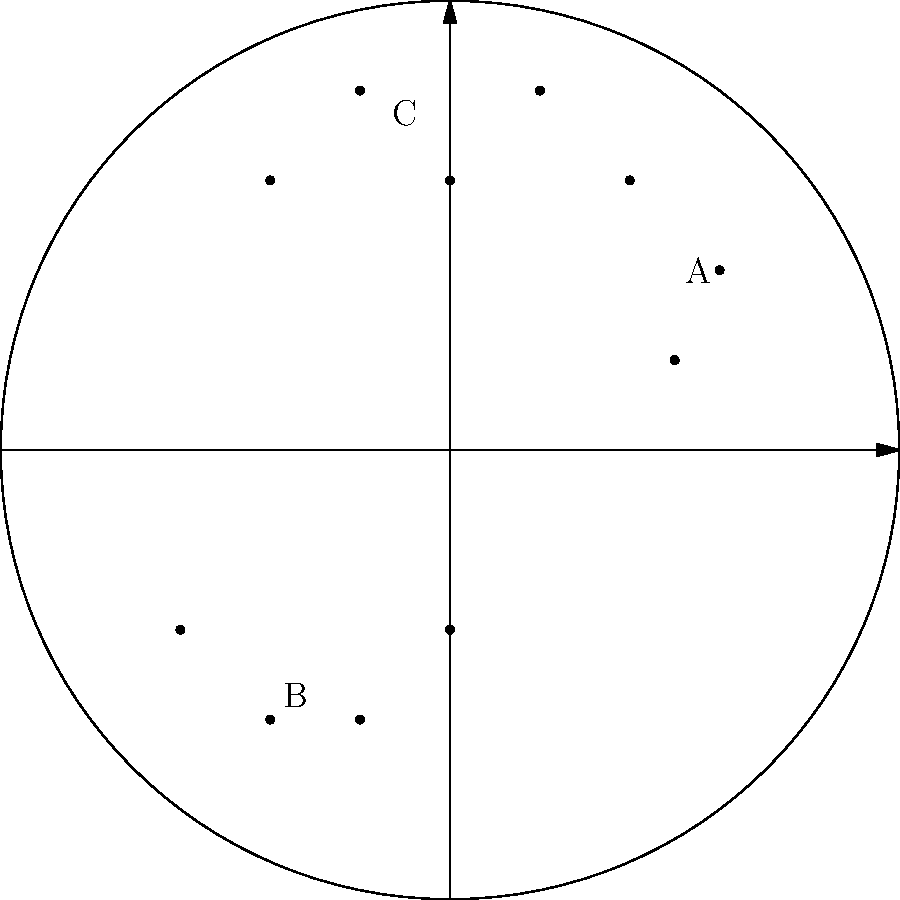In the star chart shown, which constellation resembles the letter "W" and is often used by astronomers and stargazers as a navigational tool in the northern sky? To answer this question, let's analyze the star chart step-by-step:

1. The chart shows three distinct patterns of stars, labeled A, B, and C.

2. Pattern A (on the right side) shows three stars in a nearly straight line. This is reminiscent of Orion's Belt, but it's not the constellation we're looking for.

3. Pattern B (at the bottom) shows four stars in a curved line, resembling a dipper or ladle shape. This is likely the Big Dipper, part of Ursa Major, but it doesn't match our description.

4. Pattern C (at the top) shows four stars that form a distinct "W" shape. This matches the description in the question.

5. The "W" shape is characteristic of the constellation Cassiopeia, which is indeed used as a navigational tool in the northern sky due to its distinctive shape and proximity to the North Star (Polaris).

6. Cassiopeia is circumpolar in the northern hemisphere, meaning it's visible year-round, making it a reliable reference point for navigation.

7. The "W" shape of Cassiopeia is easy to recognize, even for beginners in astronomy, which makes it particularly useful for both professional astronomers and amateur stargazers.

Given this analysis, the constellation that matches the description in the question is Cassiopeia, represented by pattern C in the star chart.
Answer: Cassiopeia 